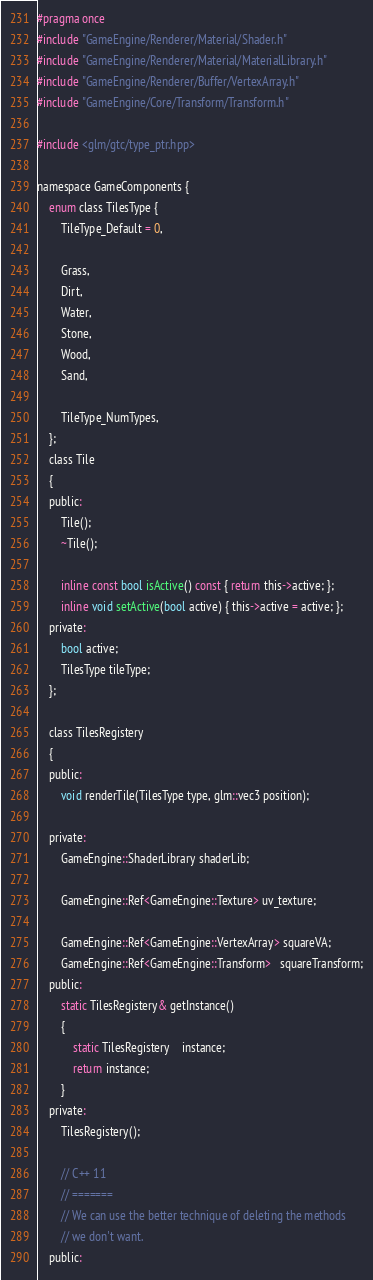Convert code to text. <code><loc_0><loc_0><loc_500><loc_500><_C_>#pragma once
#include "GameEngine/Renderer/Material/Shader.h"
#include "GameEngine/Renderer/Material/MaterialLibrary.h"
#include "GameEngine/Renderer/Buffer/VertexArray.h"
#include "GameEngine/Core/Transform/Transform.h"

#include <glm/gtc/type_ptr.hpp>

namespace GameComponents {
	enum class TilesType {
		TileType_Default = 0,

		Grass,
		Dirt,
		Water,
		Stone,
		Wood,
		Sand,

		TileType_NumTypes,
	};
	class Tile
	{
	public:
		Tile();
		~Tile();

		inline const bool isActive() const { return this->active; };
		inline void setActive(bool active) { this->active = active; };
	private:
		bool active;
		TilesType tileType;
	};
	
	class TilesRegistery
	{
	public:
		void renderTile(TilesType type, glm::vec3 position);

	private:
		GameEngine::ShaderLibrary shaderLib;

		GameEngine::Ref<GameEngine::Texture> uv_texture;

		GameEngine::Ref<GameEngine::VertexArray> squareVA;
		GameEngine::Ref<GameEngine::Transform>   squareTransform;
	public:
		static TilesRegistery& getInstance()
		{
			static TilesRegistery    instance;
			return instance;
		}
	private:
		TilesRegistery();

		// C++ 11
		// =======
		// We can use the better technique of deleting the methods
		// we don't want.
	public:</code> 